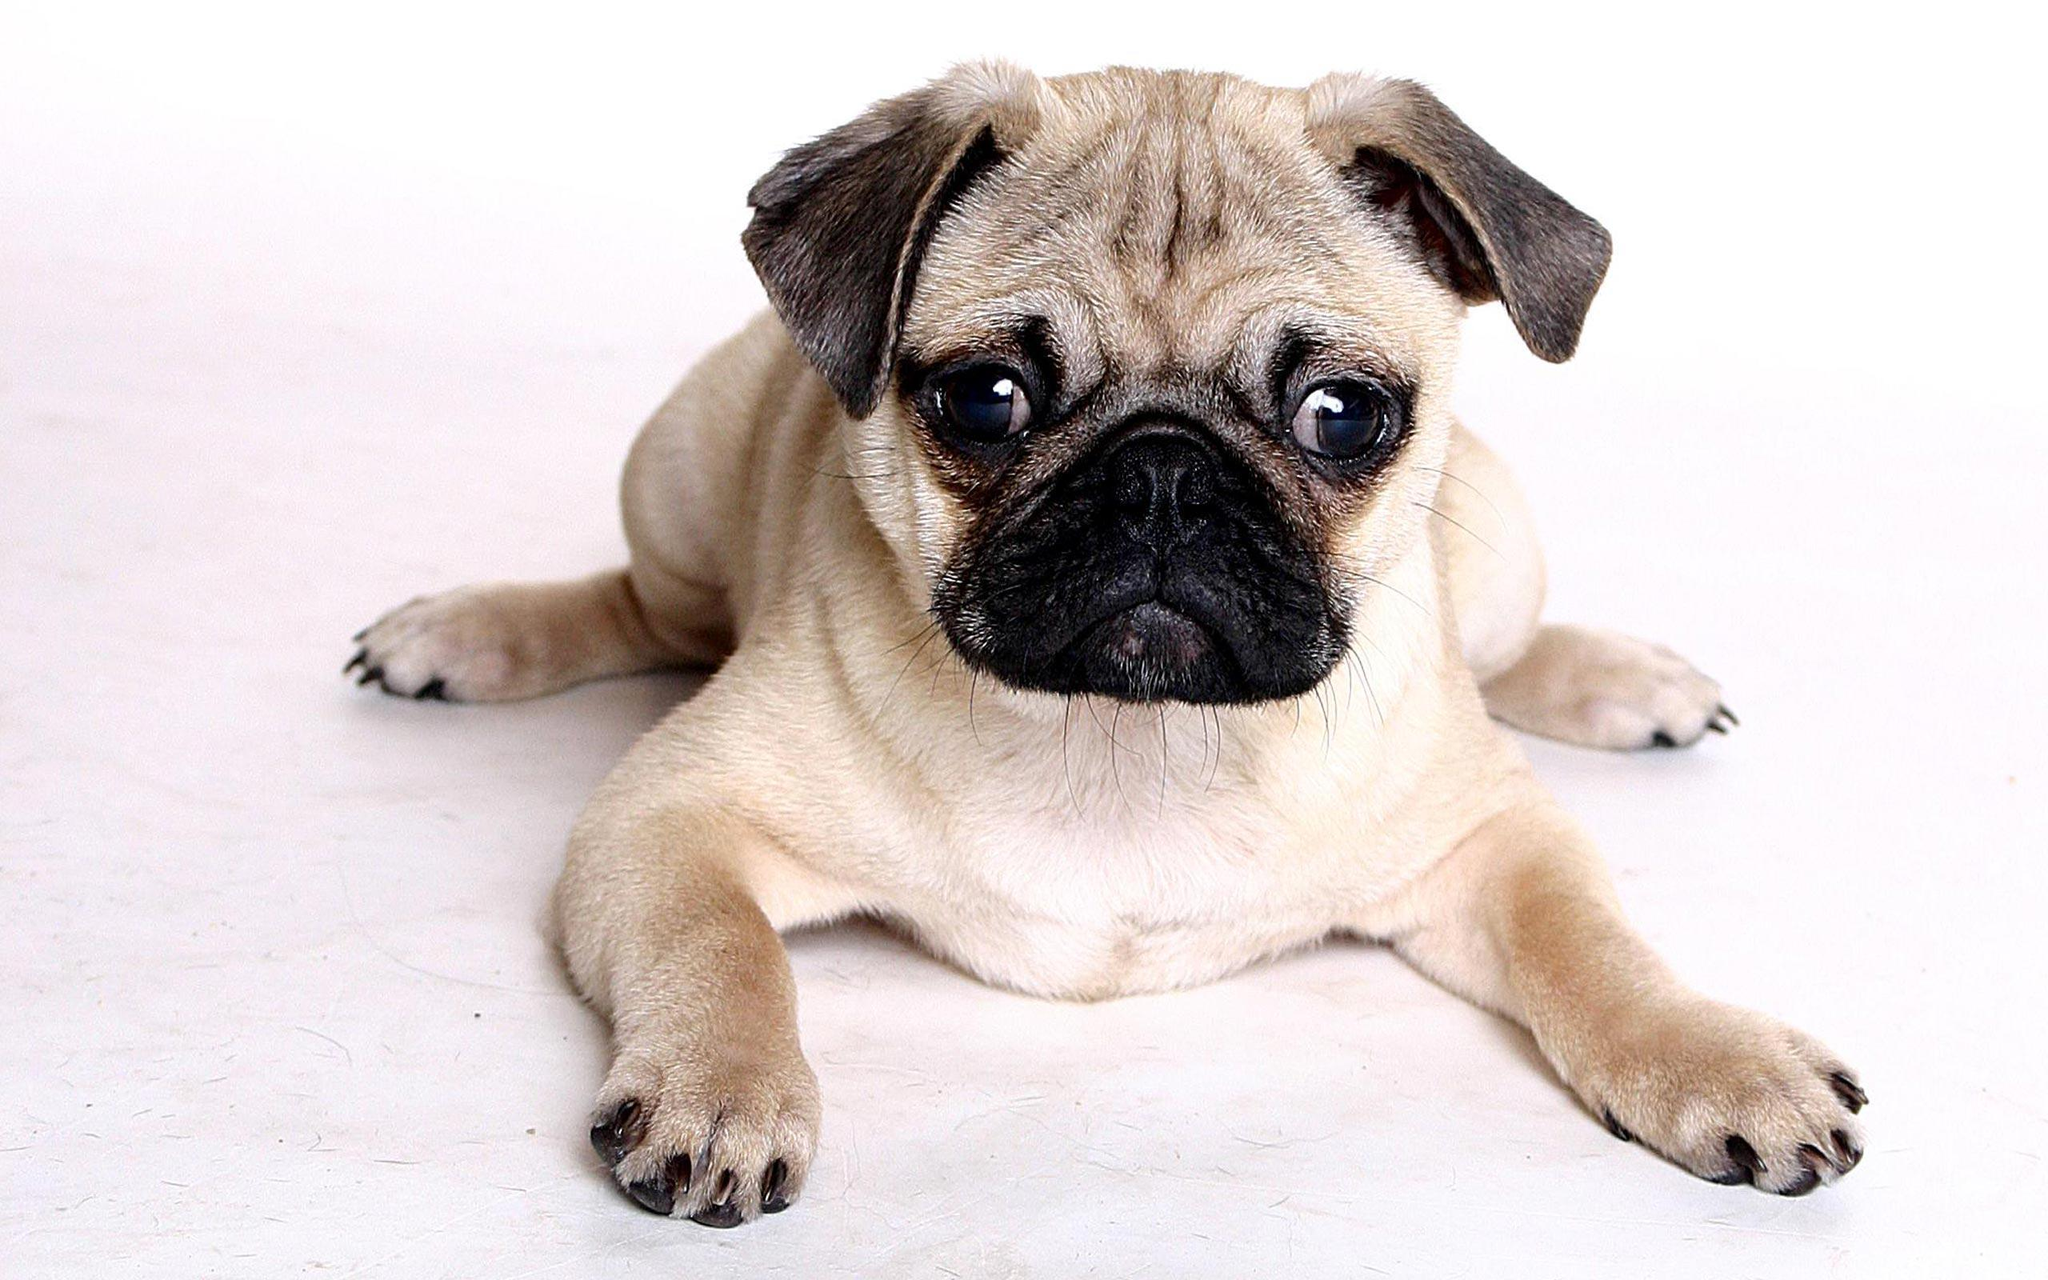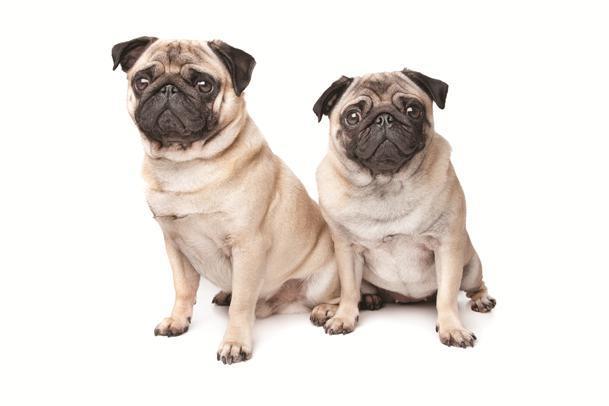The first image is the image on the left, the second image is the image on the right. Assess this claim about the two images: "There is a single dog on the left image sitting with his front legs stretched up.". Correct or not? Answer yes or no. No. 